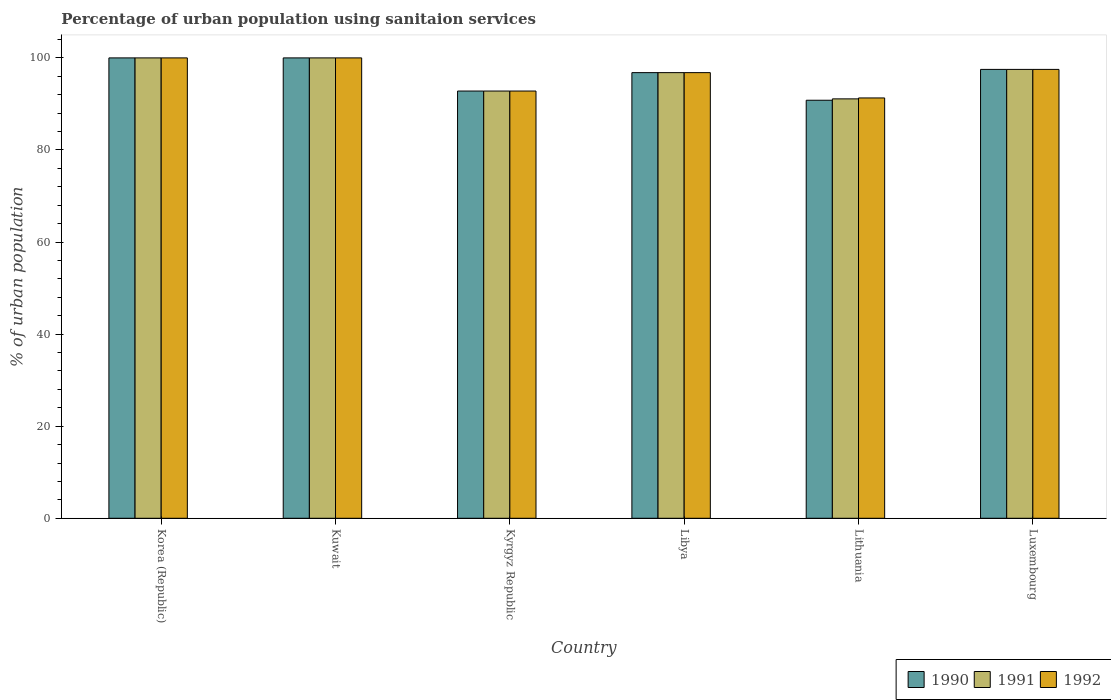How many different coloured bars are there?
Provide a succinct answer. 3. How many groups of bars are there?
Provide a succinct answer. 6. Are the number of bars per tick equal to the number of legend labels?
Your answer should be compact. Yes. Are the number of bars on each tick of the X-axis equal?
Give a very brief answer. Yes. How many bars are there on the 5th tick from the left?
Your answer should be very brief. 3. How many bars are there on the 3rd tick from the right?
Give a very brief answer. 3. In how many cases, is the number of bars for a given country not equal to the number of legend labels?
Provide a short and direct response. 0. What is the percentage of urban population using sanitaion services in 1992 in Kuwait?
Ensure brevity in your answer.  100. Across all countries, what is the maximum percentage of urban population using sanitaion services in 1992?
Provide a succinct answer. 100. Across all countries, what is the minimum percentage of urban population using sanitaion services in 1990?
Provide a succinct answer. 90.8. In which country was the percentage of urban population using sanitaion services in 1990 maximum?
Give a very brief answer. Korea (Republic). In which country was the percentage of urban population using sanitaion services in 1991 minimum?
Make the answer very short. Lithuania. What is the total percentage of urban population using sanitaion services in 1991 in the graph?
Keep it short and to the point. 578.2. What is the difference between the percentage of urban population using sanitaion services in 1990 in Kuwait and that in Lithuania?
Ensure brevity in your answer.  9.2. What is the average percentage of urban population using sanitaion services in 1990 per country?
Provide a succinct answer. 96.32. What is the ratio of the percentage of urban population using sanitaion services in 1991 in Korea (Republic) to that in Kyrgyz Republic?
Make the answer very short. 1.08. What is the difference between the highest and the second highest percentage of urban population using sanitaion services in 1991?
Give a very brief answer. -2.5. What is the difference between the highest and the lowest percentage of urban population using sanitaion services in 1990?
Keep it short and to the point. 9.2. In how many countries, is the percentage of urban population using sanitaion services in 1991 greater than the average percentage of urban population using sanitaion services in 1991 taken over all countries?
Your answer should be very brief. 4. Is the sum of the percentage of urban population using sanitaion services in 1991 in Libya and Luxembourg greater than the maximum percentage of urban population using sanitaion services in 1992 across all countries?
Ensure brevity in your answer.  Yes. What does the 3rd bar from the left in Kuwait represents?
Offer a terse response. 1992. How many bars are there?
Provide a short and direct response. 18. What is the difference between two consecutive major ticks on the Y-axis?
Your answer should be very brief. 20. Does the graph contain any zero values?
Give a very brief answer. No. Does the graph contain grids?
Provide a short and direct response. No. How many legend labels are there?
Make the answer very short. 3. How are the legend labels stacked?
Your response must be concise. Horizontal. What is the title of the graph?
Give a very brief answer. Percentage of urban population using sanitaion services. What is the label or title of the Y-axis?
Provide a short and direct response. % of urban population. What is the % of urban population in 1992 in Korea (Republic)?
Your response must be concise. 100. What is the % of urban population in 1990 in Kyrgyz Republic?
Offer a very short reply. 92.8. What is the % of urban population of 1991 in Kyrgyz Republic?
Make the answer very short. 92.8. What is the % of urban population of 1992 in Kyrgyz Republic?
Your answer should be compact. 92.8. What is the % of urban population of 1990 in Libya?
Make the answer very short. 96.8. What is the % of urban population of 1991 in Libya?
Provide a succinct answer. 96.8. What is the % of urban population of 1992 in Libya?
Offer a very short reply. 96.8. What is the % of urban population in 1990 in Lithuania?
Your response must be concise. 90.8. What is the % of urban population of 1991 in Lithuania?
Provide a succinct answer. 91.1. What is the % of urban population of 1992 in Lithuania?
Offer a terse response. 91.3. What is the % of urban population in 1990 in Luxembourg?
Your answer should be very brief. 97.5. What is the % of urban population of 1991 in Luxembourg?
Provide a short and direct response. 97.5. What is the % of urban population of 1992 in Luxembourg?
Your answer should be compact. 97.5. Across all countries, what is the maximum % of urban population of 1990?
Your response must be concise. 100. Across all countries, what is the maximum % of urban population of 1991?
Offer a terse response. 100. Across all countries, what is the minimum % of urban population of 1990?
Keep it short and to the point. 90.8. Across all countries, what is the minimum % of urban population of 1991?
Keep it short and to the point. 91.1. Across all countries, what is the minimum % of urban population in 1992?
Your answer should be very brief. 91.3. What is the total % of urban population of 1990 in the graph?
Offer a very short reply. 577.9. What is the total % of urban population in 1991 in the graph?
Your answer should be very brief. 578.2. What is the total % of urban population in 1992 in the graph?
Your answer should be very brief. 578.4. What is the difference between the % of urban population of 1990 in Korea (Republic) and that in Kuwait?
Offer a terse response. 0. What is the difference between the % of urban population in 1992 in Korea (Republic) and that in Kuwait?
Offer a terse response. 0. What is the difference between the % of urban population of 1990 in Korea (Republic) and that in Kyrgyz Republic?
Offer a terse response. 7.2. What is the difference between the % of urban population of 1992 in Korea (Republic) and that in Kyrgyz Republic?
Your answer should be very brief. 7.2. What is the difference between the % of urban population of 1991 in Korea (Republic) and that in Libya?
Ensure brevity in your answer.  3.2. What is the difference between the % of urban population of 1990 in Korea (Republic) and that in Lithuania?
Offer a very short reply. 9.2. What is the difference between the % of urban population in 1990 in Korea (Republic) and that in Luxembourg?
Offer a very short reply. 2.5. What is the difference between the % of urban population of 1991 in Korea (Republic) and that in Luxembourg?
Offer a terse response. 2.5. What is the difference between the % of urban population of 1992 in Korea (Republic) and that in Luxembourg?
Give a very brief answer. 2.5. What is the difference between the % of urban population of 1990 in Kuwait and that in Kyrgyz Republic?
Your response must be concise. 7.2. What is the difference between the % of urban population of 1991 in Kuwait and that in Kyrgyz Republic?
Ensure brevity in your answer.  7.2. What is the difference between the % of urban population in 1992 in Kuwait and that in Kyrgyz Republic?
Ensure brevity in your answer.  7.2. What is the difference between the % of urban population in 1991 in Kuwait and that in Libya?
Give a very brief answer. 3.2. What is the difference between the % of urban population in 1990 in Kuwait and that in Lithuania?
Your answer should be compact. 9.2. What is the difference between the % of urban population of 1992 in Kuwait and that in Lithuania?
Ensure brevity in your answer.  8.7. What is the difference between the % of urban population of 1992 in Kuwait and that in Luxembourg?
Offer a very short reply. 2.5. What is the difference between the % of urban population in 1992 in Kyrgyz Republic and that in Libya?
Provide a short and direct response. -4. What is the difference between the % of urban population of 1991 in Kyrgyz Republic and that in Lithuania?
Your response must be concise. 1.7. What is the difference between the % of urban population of 1992 in Kyrgyz Republic and that in Luxembourg?
Your answer should be compact. -4.7. What is the difference between the % of urban population in 1990 in Libya and that in Lithuania?
Your answer should be compact. 6. What is the difference between the % of urban population of 1992 in Libya and that in Lithuania?
Your answer should be very brief. 5.5. What is the difference between the % of urban population in 1990 in Libya and that in Luxembourg?
Offer a terse response. -0.7. What is the difference between the % of urban population in 1990 in Korea (Republic) and the % of urban population in 1991 in Kuwait?
Offer a very short reply. 0. What is the difference between the % of urban population of 1991 in Korea (Republic) and the % of urban population of 1992 in Kuwait?
Ensure brevity in your answer.  0. What is the difference between the % of urban population in 1990 in Korea (Republic) and the % of urban population in 1991 in Kyrgyz Republic?
Make the answer very short. 7.2. What is the difference between the % of urban population of 1990 in Korea (Republic) and the % of urban population of 1992 in Kyrgyz Republic?
Provide a succinct answer. 7.2. What is the difference between the % of urban population in 1991 in Korea (Republic) and the % of urban population in 1992 in Kyrgyz Republic?
Provide a succinct answer. 7.2. What is the difference between the % of urban population in 1990 in Korea (Republic) and the % of urban population in 1991 in Libya?
Give a very brief answer. 3.2. What is the difference between the % of urban population of 1991 in Korea (Republic) and the % of urban population of 1992 in Lithuania?
Offer a terse response. 8.7. What is the difference between the % of urban population of 1990 in Korea (Republic) and the % of urban population of 1991 in Luxembourg?
Provide a short and direct response. 2.5. What is the difference between the % of urban population of 1990 in Korea (Republic) and the % of urban population of 1992 in Luxembourg?
Ensure brevity in your answer.  2.5. What is the difference between the % of urban population in 1991 in Korea (Republic) and the % of urban population in 1992 in Luxembourg?
Provide a short and direct response. 2.5. What is the difference between the % of urban population of 1990 in Kuwait and the % of urban population of 1992 in Kyrgyz Republic?
Offer a terse response. 7.2. What is the difference between the % of urban population in 1990 in Kuwait and the % of urban population in 1992 in Libya?
Ensure brevity in your answer.  3.2. What is the difference between the % of urban population of 1990 in Kuwait and the % of urban population of 1992 in Lithuania?
Ensure brevity in your answer.  8.7. What is the difference between the % of urban population of 1991 in Kuwait and the % of urban population of 1992 in Lithuania?
Offer a terse response. 8.7. What is the difference between the % of urban population of 1990 in Kuwait and the % of urban population of 1992 in Luxembourg?
Offer a very short reply. 2.5. What is the difference between the % of urban population in 1990 in Kyrgyz Republic and the % of urban population in 1992 in Libya?
Give a very brief answer. -4. What is the difference between the % of urban population in 1991 in Kyrgyz Republic and the % of urban population in 1992 in Lithuania?
Offer a very short reply. 1.5. What is the difference between the % of urban population in 1990 in Kyrgyz Republic and the % of urban population in 1991 in Luxembourg?
Your response must be concise. -4.7. What is the difference between the % of urban population of 1990 in Libya and the % of urban population of 1991 in Lithuania?
Provide a succinct answer. 5.7. What is the difference between the % of urban population in 1990 in Libya and the % of urban population in 1992 in Lithuania?
Your response must be concise. 5.5. What is the difference between the % of urban population in 1990 in Libya and the % of urban population in 1991 in Luxembourg?
Your answer should be compact. -0.7. What is the difference between the % of urban population of 1990 in Lithuania and the % of urban population of 1991 in Luxembourg?
Ensure brevity in your answer.  -6.7. What is the difference between the % of urban population of 1990 in Lithuania and the % of urban population of 1992 in Luxembourg?
Provide a short and direct response. -6.7. What is the average % of urban population in 1990 per country?
Your answer should be compact. 96.32. What is the average % of urban population of 1991 per country?
Provide a succinct answer. 96.37. What is the average % of urban population in 1992 per country?
Your answer should be very brief. 96.4. What is the difference between the % of urban population in 1990 and % of urban population in 1991 in Korea (Republic)?
Your answer should be compact. 0. What is the difference between the % of urban population in 1990 and % of urban population in 1992 in Korea (Republic)?
Your answer should be very brief. 0. What is the difference between the % of urban population in 1990 and % of urban population in 1991 in Kuwait?
Provide a succinct answer. 0. What is the difference between the % of urban population of 1991 and % of urban population of 1992 in Kyrgyz Republic?
Your response must be concise. 0. What is the difference between the % of urban population in 1990 and % of urban population in 1992 in Libya?
Give a very brief answer. 0. What is the difference between the % of urban population in 1990 and % of urban population in 1991 in Lithuania?
Your answer should be very brief. -0.3. What is the difference between the % of urban population of 1990 and % of urban population of 1992 in Lithuania?
Give a very brief answer. -0.5. What is the difference between the % of urban population in 1990 and % of urban population in 1991 in Luxembourg?
Provide a short and direct response. 0. What is the difference between the % of urban population in 1990 and % of urban population in 1992 in Luxembourg?
Offer a very short reply. 0. What is the ratio of the % of urban population of 1990 in Korea (Republic) to that in Kyrgyz Republic?
Offer a very short reply. 1.08. What is the ratio of the % of urban population of 1991 in Korea (Republic) to that in Kyrgyz Republic?
Your response must be concise. 1.08. What is the ratio of the % of urban population in 1992 in Korea (Republic) to that in Kyrgyz Republic?
Your answer should be compact. 1.08. What is the ratio of the % of urban population of 1990 in Korea (Republic) to that in Libya?
Ensure brevity in your answer.  1.03. What is the ratio of the % of urban population of 1991 in Korea (Republic) to that in Libya?
Make the answer very short. 1.03. What is the ratio of the % of urban population of 1992 in Korea (Republic) to that in Libya?
Ensure brevity in your answer.  1.03. What is the ratio of the % of urban population in 1990 in Korea (Republic) to that in Lithuania?
Make the answer very short. 1.1. What is the ratio of the % of urban population in 1991 in Korea (Republic) to that in Lithuania?
Ensure brevity in your answer.  1.1. What is the ratio of the % of urban population of 1992 in Korea (Republic) to that in Lithuania?
Your answer should be compact. 1.1. What is the ratio of the % of urban population in 1990 in Korea (Republic) to that in Luxembourg?
Keep it short and to the point. 1.03. What is the ratio of the % of urban population in 1991 in Korea (Republic) to that in Luxembourg?
Give a very brief answer. 1.03. What is the ratio of the % of urban population in 1992 in Korea (Republic) to that in Luxembourg?
Offer a very short reply. 1.03. What is the ratio of the % of urban population of 1990 in Kuwait to that in Kyrgyz Republic?
Give a very brief answer. 1.08. What is the ratio of the % of urban population in 1991 in Kuwait to that in Kyrgyz Republic?
Provide a short and direct response. 1.08. What is the ratio of the % of urban population in 1992 in Kuwait to that in Kyrgyz Republic?
Keep it short and to the point. 1.08. What is the ratio of the % of urban population in 1990 in Kuwait to that in Libya?
Your response must be concise. 1.03. What is the ratio of the % of urban population in 1991 in Kuwait to that in Libya?
Provide a succinct answer. 1.03. What is the ratio of the % of urban population of 1992 in Kuwait to that in Libya?
Your answer should be compact. 1.03. What is the ratio of the % of urban population in 1990 in Kuwait to that in Lithuania?
Your answer should be compact. 1.1. What is the ratio of the % of urban population in 1991 in Kuwait to that in Lithuania?
Make the answer very short. 1.1. What is the ratio of the % of urban population of 1992 in Kuwait to that in Lithuania?
Offer a very short reply. 1.1. What is the ratio of the % of urban population in 1990 in Kuwait to that in Luxembourg?
Your response must be concise. 1.03. What is the ratio of the % of urban population of 1991 in Kuwait to that in Luxembourg?
Offer a very short reply. 1.03. What is the ratio of the % of urban population in 1992 in Kuwait to that in Luxembourg?
Your answer should be very brief. 1.03. What is the ratio of the % of urban population of 1990 in Kyrgyz Republic to that in Libya?
Your answer should be very brief. 0.96. What is the ratio of the % of urban population of 1991 in Kyrgyz Republic to that in Libya?
Offer a terse response. 0.96. What is the ratio of the % of urban population of 1992 in Kyrgyz Republic to that in Libya?
Keep it short and to the point. 0.96. What is the ratio of the % of urban population in 1990 in Kyrgyz Republic to that in Lithuania?
Offer a terse response. 1.02. What is the ratio of the % of urban population of 1991 in Kyrgyz Republic to that in Lithuania?
Your answer should be very brief. 1.02. What is the ratio of the % of urban population of 1992 in Kyrgyz Republic to that in Lithuania?
Keep it short and to the point. 1.02. What is the ratio of the % of urban population of 1990 in Kyrgyz Republic to that in Luxembourg?
Give a very brief answer. 0.95. What is the ratio of the % of urban population in 1991 in Kyrgyz Republic to that in Luxembourg?
Offer a terse response. 0.95. What is the ratio of the % of urban population of 1992 in Kyrgyz Republic to that in Luxembourg?
Offer a terse response. 0.95. What is the ratio of the % of urban population of 1990 in Libya to that in Lithuania?
Offer a terse response. 1.07. What is the ratio of the % of urban population in 1991 in Libya to that in Lithuania?
Your answer should be very brief. 1.06. What is the ratio of the % of urban population of 1992 in Libya to that in Lithuania?
Your answer should be compact. 1.06. What is the ratio of the % of urban population of 1991 in Libya to that in Luxembourg?
Keep it short and to the point. 0.99. What is the ratio of the % of urban population in 1992 in Libya to that in Luxembourg?
Ensure brevity in your answer.  0.99. What is the ratio of the % of urban population of 1990 in Lithuania to that in Luxembourg?
Your answer should be compact. 0.93. What is the ratio of the % of urban population of 1991 in Lithuania to that in Luxembourg?
Offer a very short reply. 0.93. What is the ratio of the % of urban population in 1992 in Lithuania to that in Luxembourg?
Provide a short and direct response. 0.94. What is the difference between the highest and the second highest % of urban population in 1991?
Your answer should be very brief. 0. What is the difference between the highest and the lowest % of urban population in 1991?
Your response must be concise. 8.9. What is the difference between the highest and the lowest % of urban population of 1992?
Your response must be concise. 8.7. 